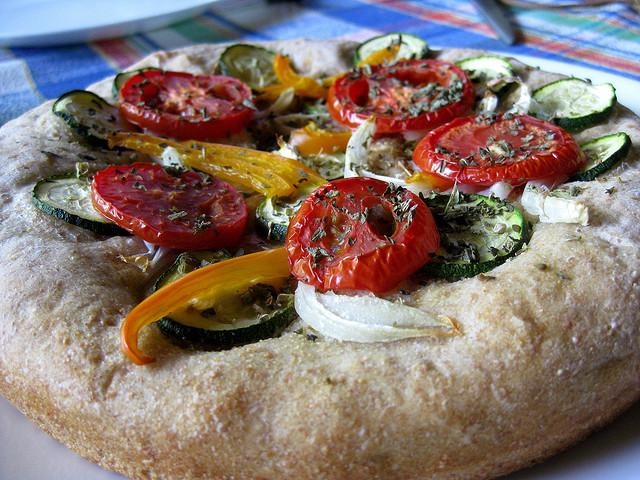What is the orange vegetable called?
Short answer required. Pepper. Does this pizza look greasy?
Keep it brief. No. Is this gluten free dough?
Be succinct. No. 